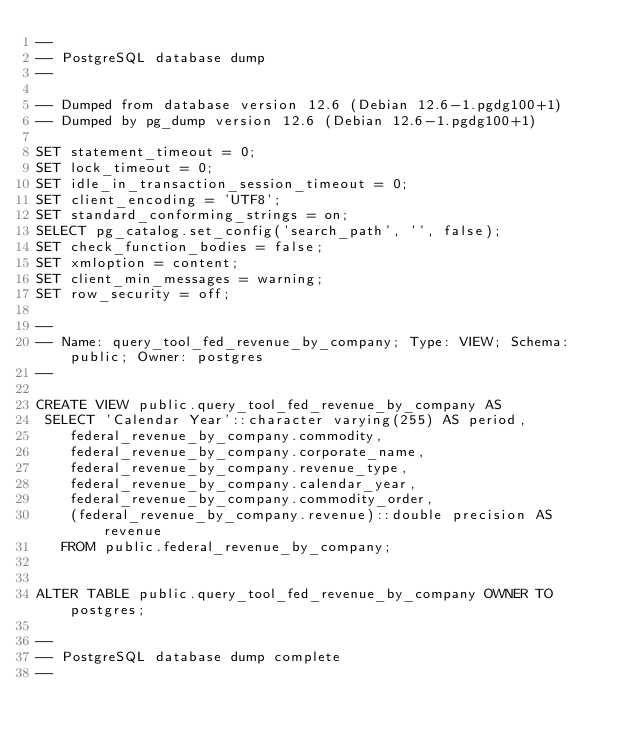Convert code to text. <code><loc_0><loc_0><loc_500><loc_500><_SQL_>--
-- PostgreSQL database dump
--

-- Dumped from database version 12.6 (Debian 12.6-1.pgdg100+1)
-- Dumped by pg_dump version 12.6 (Debian 12.6-1.pgdg100+1)

SET statement_timeout = 0;
SET lock_timeout = 0;
SET idle_in_transaction_session_timeout = 0;
SET client_encoding = 'UTF8';
SET standard_conforming_strings = on;
SELECT pg_catalog.set_config('search_path', '', false);
SET check_function_bodies = false;
SET xmloption = content;
SET client_min_messages = warning;
SET row_security = off;

--
-- Name: query_tool_fed_revenue_by_company; Type: VIEW; Schema: public; Owner: postgres
--

CREATE VIEW public.query_tool_fed_revenue_by_company AS
 SELECT 'Calendar Year'::character varying(255) AS period,
    federal_revenue_by_company.commodity,
    federal_revenue_by_company.corporate_name,
    federal_revenue_by_company.revenue_type,
    federal_revenue_by_company.calendar_year,
    federal_revenue_by_company.commodity_order,
    (federal_revenue_by_company.revenue)::double precision AS revenue
   FROM public.federal_revenue_by_company;


ALTER TABLE public.query_tool_fed_revenue_by_company OWNER TO postgres;

--
-- PostgreSQL database dump complete
--

</code> 